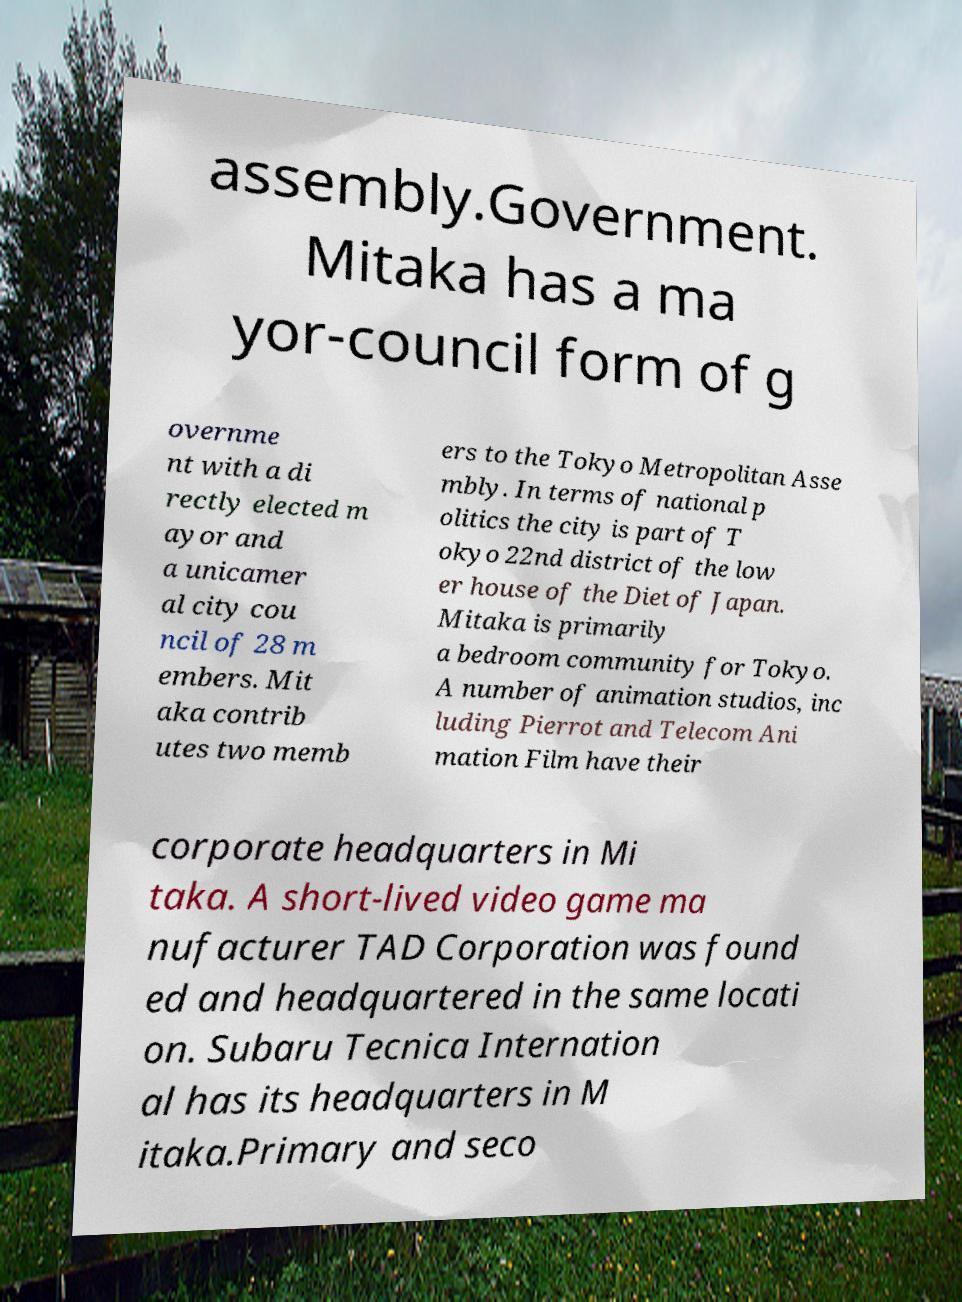What messages or text are displayed in this image? I need them in a readable, typed format. assembly.Government. Mitaka has a ma yor-council form of g overnme nt with a di rectly elected m ayor and a unicamer al city cou ncil of 28 m embers. Mit aka contrib utes two memb ers to the Tokyo Metropolitan Asse mbly. In terms of national p olitics the city is part of T okyo 22nd district of the low er house of the Diet of Japan. Mitaka is primarily a bedroom community for Tokyo. A number of animation studios, inc luding Pierrot and Telecom Ani mation Film have their corporate headquarters in Mi taka. A short-lived video game ma nufacturer TAD Corporation was found ed and headquartered in the same locati on. Subaru Tecnica Internation al has its headquarters in M itaka.Primary and seco 